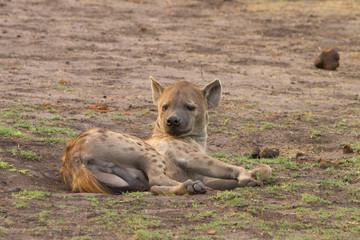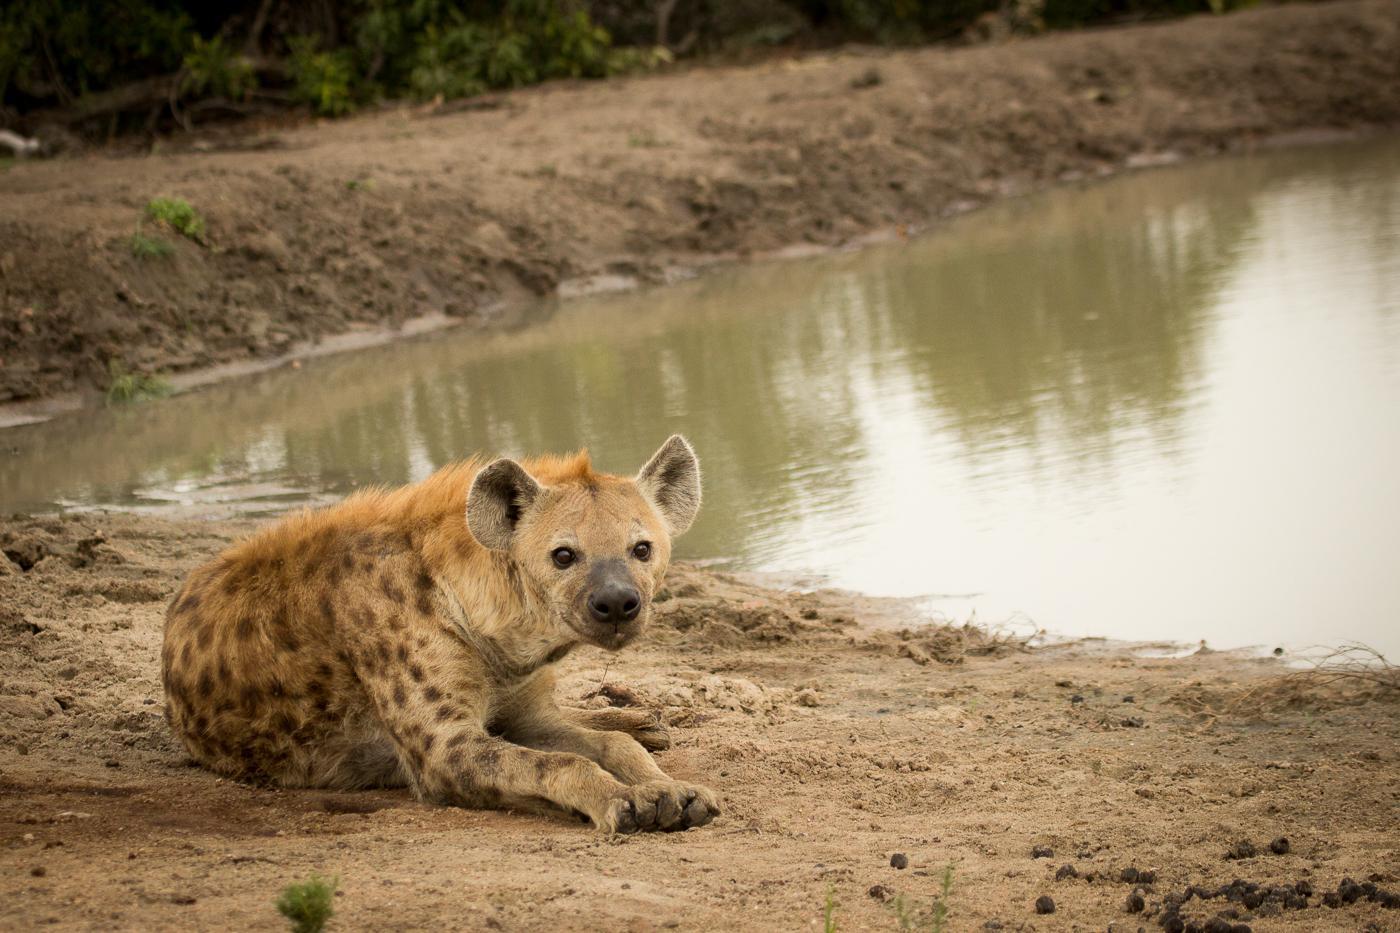The first image is the image on the left, the second image is the image on the right. Assess this claim about the two images: "The left image features one adult hyena lying flat on its belly, and the right image includes an adult hyena reclining in some position.". Correct or not? Answer yes or no. No. The first image is the image on the left, the second image is the image on the right. Examine the images to the left and right. Is the description "The animal in one of the images has its head laying directly on the ground." accurate? Answer yes or no. No. 